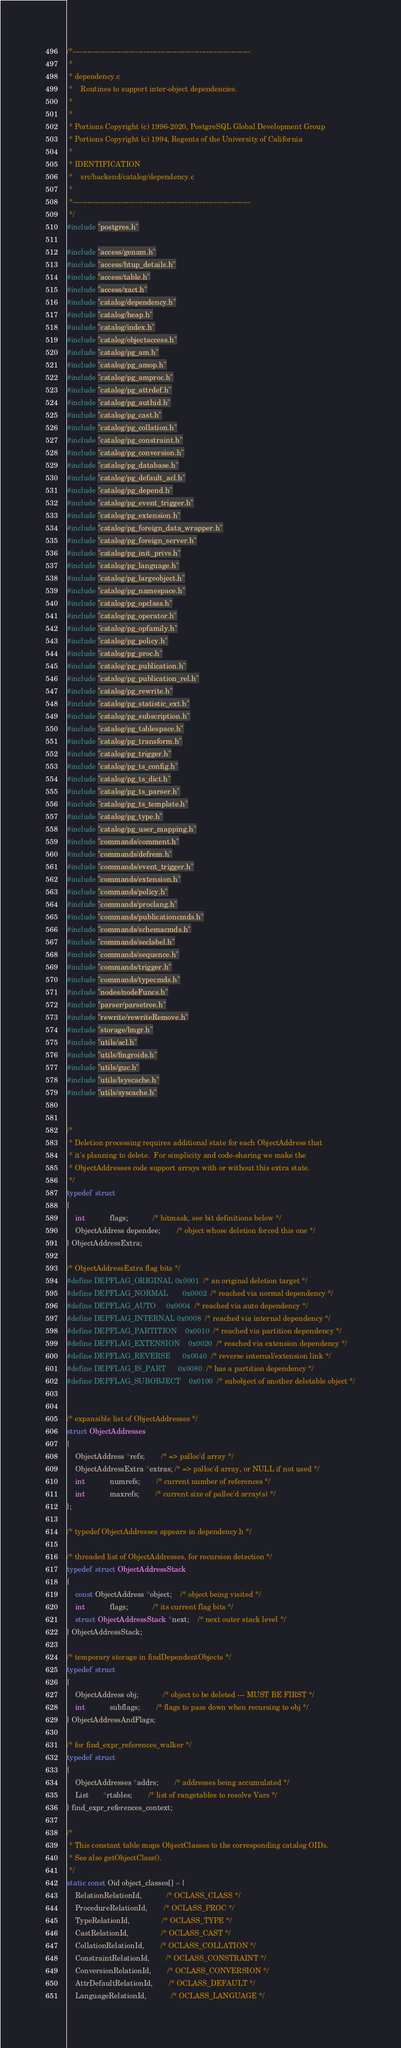Convert code to text. <code><loc_0><loc_0><loc_500><loc_500><_C_>/*-------------------------------------------------------------------------
 *
 * dependency.c
 *	  Routines to support inter-object dependencies.
 *
 *
 * Portions Copyright (c) 1996-2020, PostgreSQL Global Development Group
 * Portions Copyright (c) 1994, Regents of the University of California
 *
 * IDENTIFICATION
 *	  src/backend/catalog/dependency.c
 *
 *-------------------------------------------------------------------------
 */
#include "postgres.h"

#include "access/genam.h"
#include "access/htup_details.h"
#include "access/table.h"
#include "access/xact.h"
#include "catalog/dependency.h"
#include "catalog/heap.h"
#include "catalog/index.h"
#include "catalog/objectaccess.h"
#include "catalog/pg_am.h"
#include "catalog/pg_amop.h"
#include "catalog/pg_amproc.h"
#include "catalog/pg_attrdef.h"
#include "catalog/pg_authid.h"
#include "catalog/pg_cast.h"
#include "catalog/pg_collation.h"
#include "catalog/pg_constraint.h"
#include "catalog/pg_conversion.h"
#include "catalog/pg_database.h"
#include "catalog/pg_default_acl.h"
#include "catalog/pg_depend.h"
#include "catalog/pg_event_trigger.h"
#include "catalog/pg_extension.h"
#include "catalog/pg_foreign_data_wrapper.h"
#include "catalog/pg_foreign_server.h"
#include "catalog/pg_init_privs.h"
#include "catalog/pg_language.h"
#include "catalog/pg_largeobject.h"
#include "catalog/pg_namespace.h"
#include "catalog/pg_opclass.h"
#include "catalog/pg_operator.h"
#include "catalog/pg_opfamily.h"
#include "catalog/pg_policy.h"
#include "catalog/pg_proc.h"
#include "catalog/pg_publication.h"
#include "catalog/pg_publication_rel.h"
#include "catalog/pg_rewrite.h"
#include "catalog/pg_statistic_ext.h"
#include "catalog/pg_subscription.h"
#include "catalog/pg_tablespace.h"
#include "catalog/pg_transform.h"
#include "catalog/pg_trigger.h"
#include "catalog/pg_ts_config.h"
#include "catalog/pg_ts_dict.h"
#include "catalog/pg_ts_parser.h"
#include "catalog/pg_ts_template.h"
#include "catalog/pg_type.h"
#include "catalog/pg_user_mapping.h"
#include "commands/comment.h"
#include "commands/defrem.h"
#include "commands/event_trigger.h"
#include "commands/extension.h"
#include "commands/policy.h"
#include "commands/proclang.h"
#include "commands/publicationcmds.h"
#include "commands/schemacmds.h"
#include "commands/seclabel.h"
#include "commands/sequence.h"
#include "commands/trigger.h"
#include "commands/typecmds.h"
#include "nodes/nodeFuncs.h"
#include "parser/parsetree.h"
#include "rewrite/rewriteRemove.h"
#include "storage/lmgr.h"
#include "utils/acl.h"
#include "utils/fmgroids.h"
#include "utils/guc.h"
#include "utils/lsyscache.h"
#include "utils/syscache.h"


/*
 * Deletion processing requires additional state for each ObjectAddress that
 * it's planning to delete.  For simplicity and code-sharing we make the
 * ObjectAddresses code support arrays with or without this extra state.
 */
typedef struct
{
	int			flags;			/* bitmask, see bit definitions below */
	ObjectAddress dependee;		/* object whose deletion forced this one */
} ObjectAddressExtra;

/* ObjectAddressExtra flag bits */
#define DEPFLAG_ORIGINAL	0x0001	/* an original deletion target */
#define DEPFLAG_NORMAL		0x0002	/* reached via normal dependency */
#define DEPFLAG_AUTO		0x0004	/* reached via auto dependency */
#define DEPFLAG_INTERNAL	0x0008	/* reached via internal dependency */
#define DEPFLAG_PARTITION	0x0010	/* reached via partition dependency */
#define DEPFLAG_EXTENSION	0x0020	/* reached via extension dependency */
#define DEPFLAG_REVERSE		0x0040	/* reverse internal/extension link */
#define DEPFLAG_IS_PART		0x0080	/* has a partition dependency */
#define DEPFLAG_SUBOBJECT	0x0100	/* subobject of another deletable object */


/* expansible list of ObjectAddresses */
struct ObjectAddresses
{
	ObjectAddress *refs;		/* => palloc'd array */
	ObjectAddressExtra *extras; /* => palloc'd array, or NULL if not used */
	int			numrefs;		/* current number of references */
	int			maxrefs;		/* current size of palloc'd array(s) */
};

/* typedef ObjectAddresses appears in dependency.h */

/* threaded list of ObjectAddresses, for recursion detection */
typedef struct ObjectAddressStack
{
	const ObjectAddress *object;	/* object being visited */
	int			flags;			/* its current flag bits */
	struct ObjectAddressStack *next;	/* next outer stack level */
} ObjectAddressStack;

/* temporary storage in findDependentObjects */
typedef struct
{
	ObjectAddress obj;			/* object to be deleted --- MUST BE FIRST */
	int			subflags;		/* flags to pass down when recursing to obj */
} ObjectAddressAndFlags;

/* for find_expr_references_walker */
typedef struct
{
	ObjectAddresses *addrs;		/* addresses being accumulated */
	List	   *rtables;		/* list of rangetables to resolve Vars */
} find_expr_references_context;

/*
 * This constant table maps ObjectClasses to the corresponding catalog OIDs.
 * See also getObjectClass().
 */
static const Oid object_classes[] = {
	RelationRelationId,			/* OCLASS_CLASS */
	ProcedureRelationId,		/* OCLASS_PROC */
	TypeRelationId,				/* OCLASS_TYPE */
	CastRelationId,				/* OCLASS_CAST */
	CollationRelationId,		/* OCLASS_COLLATION */
	ConstraintRelationId,		/* OCLASS_CONSTRAINT */
	ConversionRelationId,		/* OCLASS_CONVERSION */
	AttrDefaultRelationId,		/* OCLASS_DEFAULT */
	LanguageRelationId,			/* OCLASS_LANGUAGE */</code> 